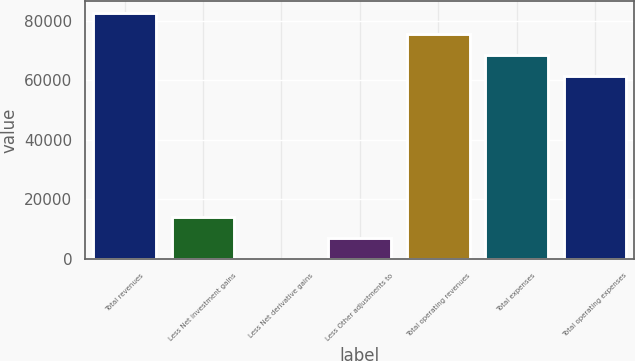<chart> <loc_0><loc_0><loc_500><loc_500><bar_chart><fcel>Total revenues<fcel>Less Net investment gains<fcel>Less Net derivative gains<fcel>Less Other adjustments to<fcel>Total operating revenues<fcel>Total expenses<fcel>Total operating expenses<nl><fcel>82517.9<fcel>14020.6<fcel>38<fcel>7029.3<fcel>75526.6<fcel>68535.3<fcel>61544<nl></chart> 